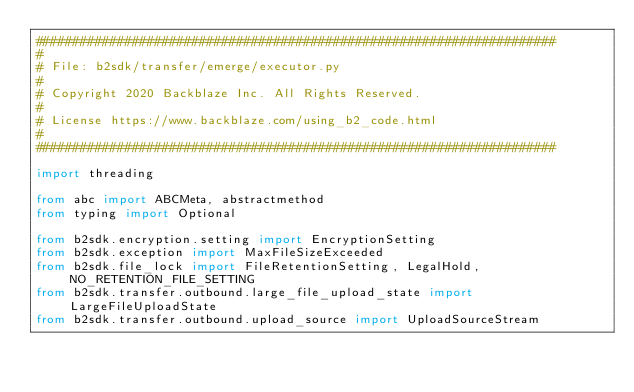Convert code to text. <code><loc_0><loc_0><loc_500><loc_500><_Python_>######################################################################
#
# File: b2sdk/transfer/emerge/executor.py
#
# Copyright 2020 Backblaze Inc. All Rights Reserved.
#
# License https://www.backblaze.com/using_b2_code.html
#
######################################################################

import threading

from abc import ABCMeta, abstractmethod
from typing import Optional

from b2sdk.encryption.setting import EncryptionSetting
from b2sdk.exception import MaxFileSizeExceeded
from b2sdk.file_lock import FileRetentionSetting, LegalHold, NO_RETENTION_FILE_SETTING
from b2sdk.transfer.outbound.large_file_upload_state import LargeFileUploadState
from b2sdk.transfer.outbound.upload_source import UploadSourceStream</code> 